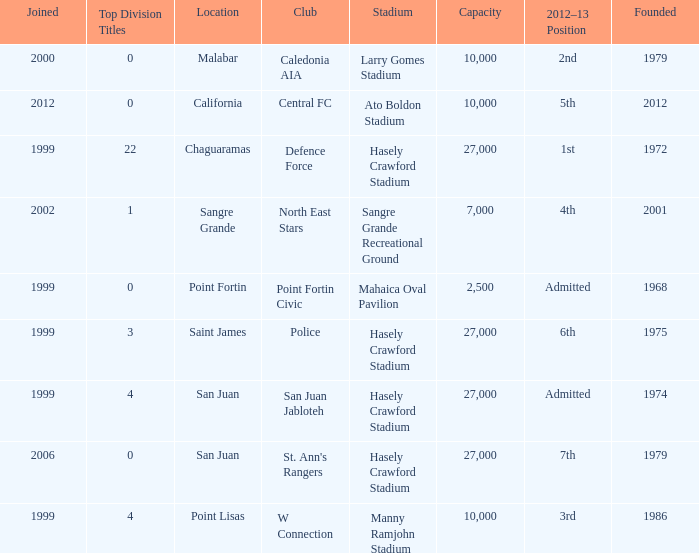Which stadium was used for the North East Stars club? Sangre Grande Recreational Ground. 